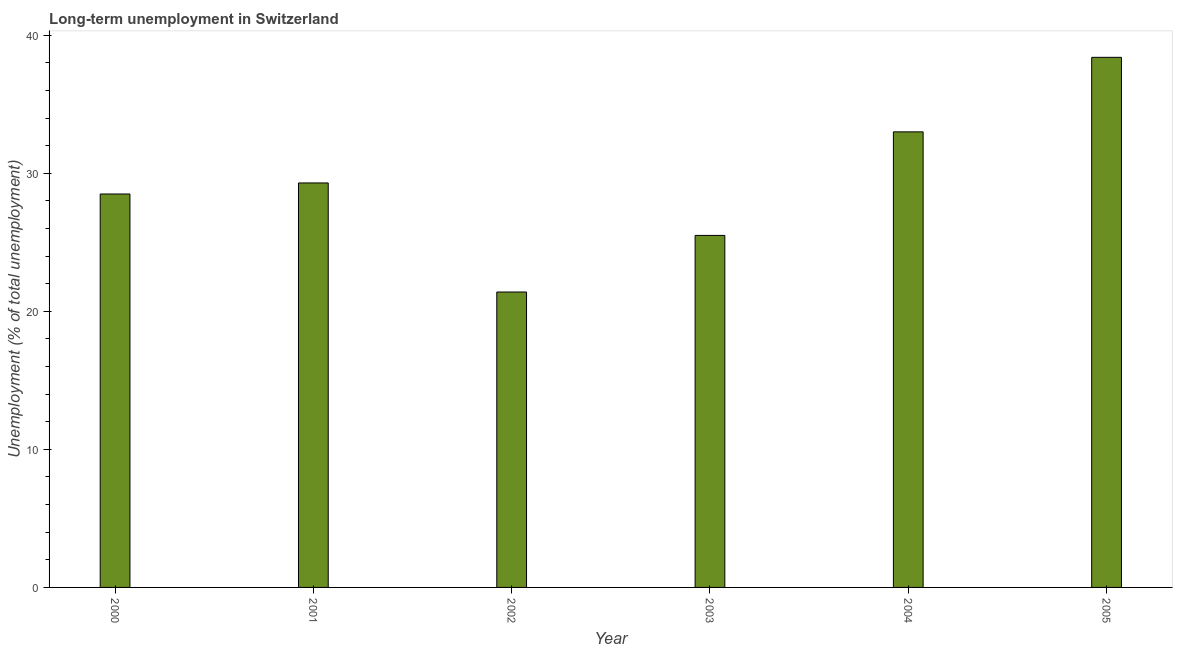Does the graph contain grids?
Make the answer very short. No. What is the title of the graph?
Offer a terse response. Long-term unemployment in Switzerland. What is the label or title of the Y-axis?
Your answer should be very brief. Unemployment (% of total unemployment). What is the long-term unemployment in 2005?
Provide a short and direct response. 38.4. Across all years, what is the maximum long-term unemployment?
Offer a very short reply. 38.4. Across all years, what is the minimum long-term unemployment?
Your answer should be compact. 21.4. In which year was the long-term unemployment maximum?
Your response must be concise. 2005. In which year was the long-term unemployment minimum?
Provide a short and direct response. 2002. What is the sum of the long-term unemployment?
Offer a very short reply. 176.1. What is the difference between the long-term unemployment in 2002 and 2005?
Your response must be concise. -17. What is the average long-term unemployment per year?
Your answer should be compact. 29.35. What is the median long-term unemployment?
Your answer should be very brief. 28.9. In how many years, is the long-term unemployment greater than 32 %?
Provide a succinct answer. 2. What is the ratio of the long-term unemployment in 2003 to that in 2004?
Keep it short and to the point. 0.77. What is the difference between the highest and the second highest long-term unemployment?
Your answer should be compact. 5.4. What is the difference between the highest and the lowest long-term unemployment?
Ensure brevity in your answer.  17. In how many years, is the long-term unemployment greater than the average long-term unemployment taken over all years?
Give a very brief answer. 2. How many bars are there?
Provide a succinct answer. 6. Are all the bars in the graph horizontal?
Your answer should be compact. No. How many years are there in the graph?
Make the answer very short. 6. What is the Unemployment (% of total unemployment) of 2000?
Provide a short and direct response. 28.5. What is the Unemployment (% of total unemployment) of 2001?
Your answer should be very brief. 29.3. What is the Unemployment (% of total unemployment) of 2002?
Offer a very short reply. 21.4. What is the Unemployment (% of total unemployment) in 2004?
Give a very brief answer. 33. What is the Unemployment (% of total unemployment) in 2005?
Ensure brevity in your answer.  38.4. What is the difference between the Unemployment (% of total unemployment) in 2000 and 2001?
Your answer should be compact. -0.8. What is the difference between the Unemployment (% of total unemployment) in 2000 and 2004?
Make the answer very short. -4.5. What is the difference between the Unemployment (% of total unemployment) in 2001 and 2002?
Your answer should be compact. 7.9. What is the difference between the Unemployment (% of total unemployment) in 2001 and 2003?
Offer a very short reply. 3.8. What is the difference between the Unemployment (% of total unemployment) in 2002 and 2003?
Your response must be concise. -4.1. What is the difference between the Unemployment (% of total unemployment) in 2003 and 2004?
Provide a succinct answer. -7.5. What is the ratio of the Unemployment (% of total unemployment) in 2000 to that in 2001?
Make the answer very short. 0.97. What is the ratio of the Unemployment (% of total unemployment) in 2000 to that in 2002?
Provide a short and direct response. 1.33. What is the ratio of the Unemployment (% of total unemployment) in 2000 to that in 2003?
Your answer should be very brief. 1.12. What is the ratio of the Unemployment (% of total unemployment) in 2000 to that in 2004?
Offer a very short reply. 0.86. What is the ratio of the Unemployment (% of total unemployment) in 2000 to that in 2005?
Offer a very short reply. 0.74. What is the ratio of the Unemployment (% of total unemployment) in 2001 to that in 2002?
Ensure brevity in your answer.  1.37. What is the ratio of the Unemployment (% of total unemployment) in 2001 to that in 2003?
Offer a very short reply. 1.15. What is the ratio of the Unemployment (% of total unemployment) in 2001 to that in 2004?
Provide a succinct answer. 0.89. What is the ratio of the Unemployment (% of total unemployment) in 2001 to that in 2005?
Provide a succinct answer. 0.76. What is the ratio of the Unemployment (% of total unemployment) in 2002 to that in 2003?
Give a very brief answer. 0.84. What is the ratio of the Unemployment (% of total unemployment) in 2002 to that in 2004?
Make the answer very short. 0.65. What is the ratio of the Unemployment (% of total unemployment) in 2002 to that in 2005?
Your response must be concise. 0.56. What is the ratio of the Unemployment (% of total unemployment) in 2003 to that in 2004?
Your response must be concise. 0.77. What is the ratio of the Unemployment (% of total unemployment) in 2003 to that in 2005?
Give a very brief answer. 0.66. What is the ratio of the Unemployment (% of total unemployment) in 2004 to that in 2005?
Ensure brevity in your answer.  0.86. 